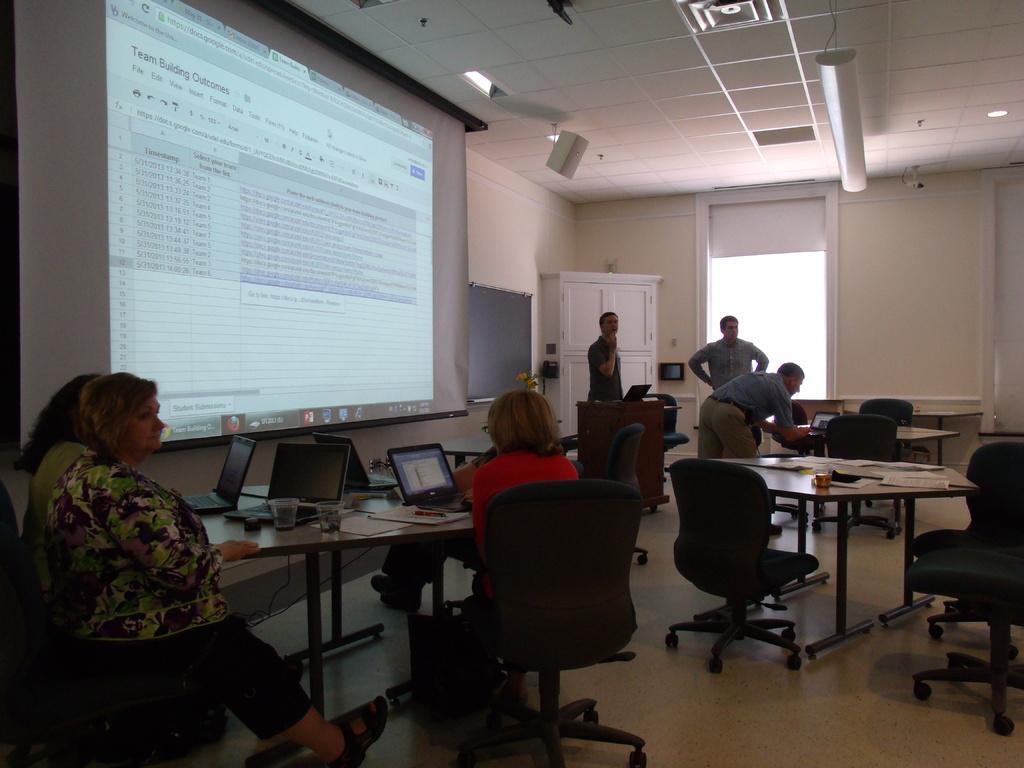In one or two sentences, can you explain what this image depicts? This picture shows a group of people seated with their laptops on the table and we see three men standing and we see a projector screen and we see couple of chairs and tables 